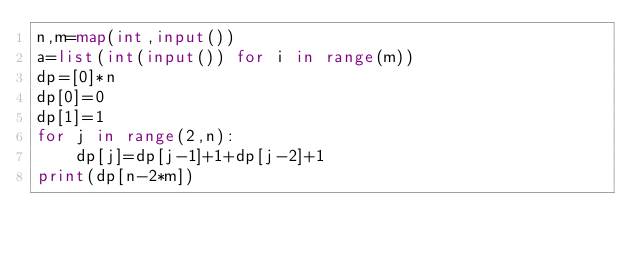Convert code to text. <code><loc_0><loc_0><loc_500><loc_500><_Python_>n,m=map(int,input())
a=list(int(input()) for i in range(m))
dp=[0]*n
dp[0]=0
dp[1]=1
for j in range(2,n):
    dp[j]=dp[j-1]+1+dp[j-2]+1
print(dp[n-2*m])
</code> 